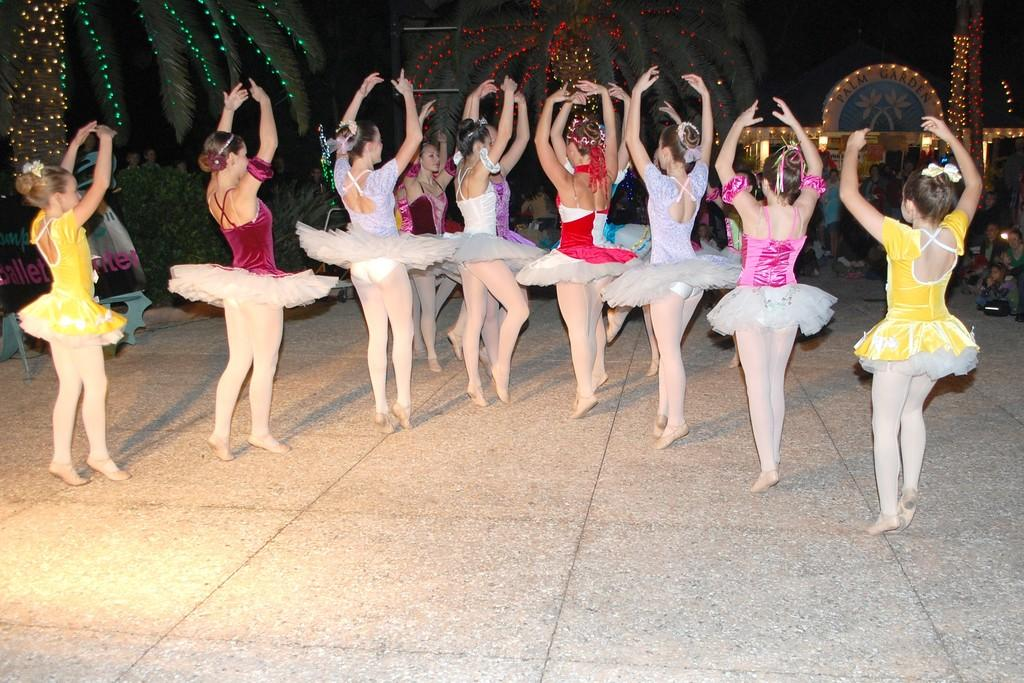What are the girls in the image doing? There is a group of girls dancing in the image. Where are the girls dancing? The girls are dancing on the floor. What can be seen in the background of the image? There are trees visible in the image. How are the trees illuminated? The trees have lighting. What are the people in the image doing? There are people seated in the image, and they are watching the dancing girls. What is the building in the image decorated with? The building in the image has serial lights. What type of insurance policy do the trees in the image provide? There is no mention of insurance in the image, and the trees are not providing any insurance. What color vest is the tree wearing in the image? There is no tree wearing a vest in the image, as trees do not wear clothing. 